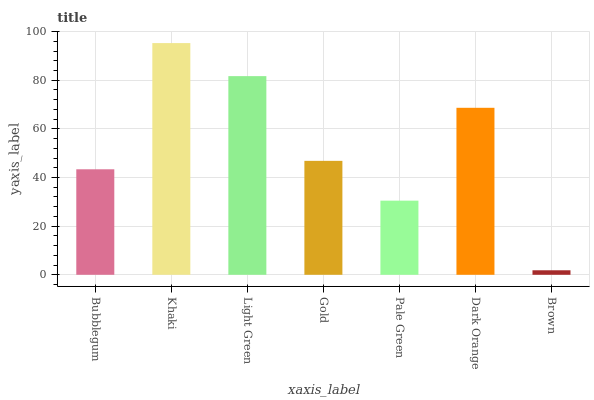Is Brown the minimum?
Answer yes or no. Yes. Is Khaki the maximum?
Answer yes or no. Yes. Is Light Green the minimum?
Answer yes or no. No. Is Light Green the maximum?
Answer yes or no. No. Is Khaki greater than Light Green?
Answer yes or no. Yes. Is Light Green less than Khaki?
Answer yes or no. Yes. Is Light Green greater than Khaki?
Answer yes or no. No. Is Khaki less than Light Green?
Answer yes or no. No. Is Gold the high median?
Answer yes or no. Yes. Is Gold the low median?
Answer yes or no. Yes. Is Brown the high median?
Answer yes or no. No. Is Khaki the low median?
Answer yes or no. No. 